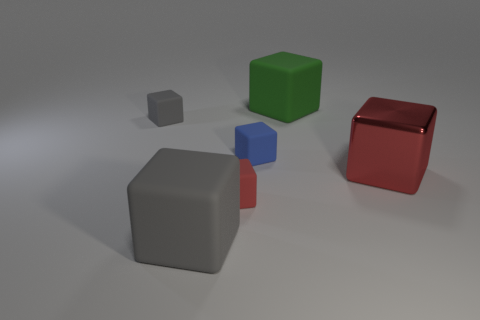Subtract all large gray rubber cubes. How many cubes are left? 5 Add 2 blue objects. How many objects exist? 8 Subtract all gray cubes. How many cubes are left? 4 Subtract 2 cubes. How many cubes are left? 4 Subtract all yellow cylinders. How many red cubes are left? 2 Subtract all gray blocks. Subtract all purple spheres. How many blocks are left? 4 Subtract all small blocks. Subtract all small red matte objects. How many objects are left? 2 Add 2 blue rubber things. How many blue rubber things are left? 3 Add 5 gray cylinders. How many gray cylinders exist? 5 Subtract 0 gray cylinders. How many objects are left? 6 